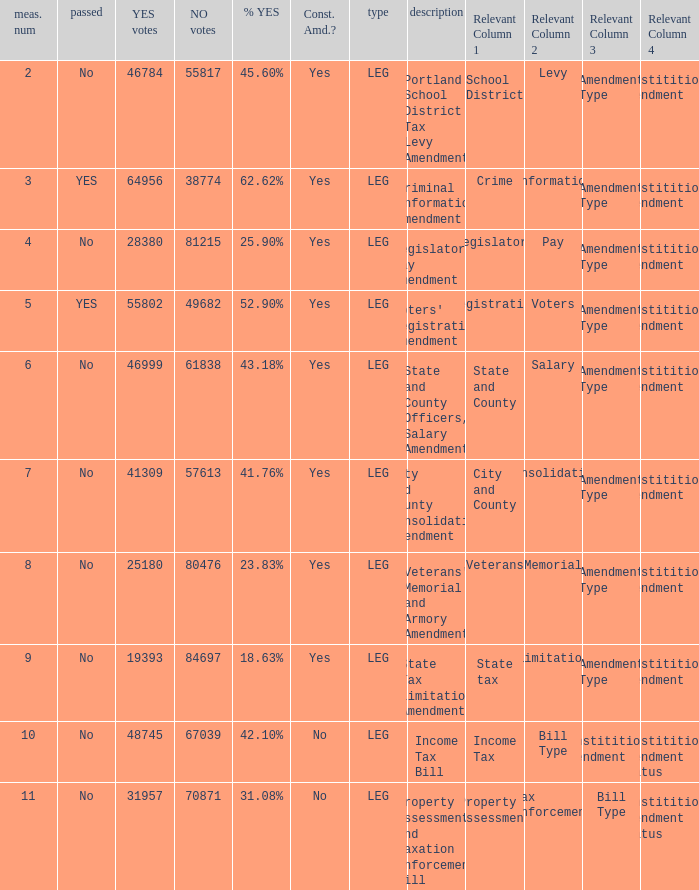Could you parse the entire table as a dict? {'header': ['meas. num', 'passed', 'YES votes', 'NO votes', '% YES', 'Const. Amd.?', 'type', 'description', 'Relevant Column 1', 'Relevant Column 2', 'Relevant Column 3', 'Relevant Column 4'], 'rows': [['2', 'No', '46784', '55817', '45.60%', 'Yes', 'LEG', 'Portland School District Tax Levy Amendment', 'School District', 'Levy', 'Amendment Type', 'Constititional Amendment'], ['3', 'YES', '64956', '38774', '62.62%', 'Yes', 'LEG', 'Criminal Information Amendment', 'Crime', 'Information', 'Amendment Type', 'Constititional Amendment'], ['4', 'No', '28380', '81215', '25.90%', 'Yes', 'LEG', "Legislators' Pay Amendment", 'Legislators', 'Pay', 'Amendment Type', 'Constititional Amendment'], ['5', 'YES', '55802', '49682', '52.90%', 'Yes', 'LEG', "Voters' Registration Amendment", 'Registration', 'Voters', 'Amendment Type', 'Constititional Amendment'], ['6', 'No', '46999', '61838', '43.18%', 'Yes', 'LEG', 'State and County Officers, Salary Amendment', 'State and County', 'Salary', 'Amendment Type', 'Constititional Amendment'], ['7', 'No', '41309', '57613', '41.76%', 'Yes', 'LEG', 'City and County Consolidation Amendment', 'City and County', 'Consolidation', 'Amendment Type', 'Constititional Amendment'], ['8', 'No', '25180', '80476', '23.83%', 'Yes', 'LEG', "Veterans' Memorial and Armory Amendment", 'Veterans', 'Memorial', 'Amendment Type', 'Constititional Amendment'], ['9', 'No', '19393', '84697', '18.63%', 'Yes', 'LEG', 'State Tax Limitation Amendment', 'State tax', 'Limitation', 'Amendment Type', 'Constititional Amendment'], ['10', 'No', '48745', '67039', '42.10%', 'No', 'LEG', 'Income Tax Bill', 'Income Tax', 'Bill Type', 'Constititional Amendment', 'Constititional Amendment Status'], ['11', 'No', '31957', '70871', '31.08%', 'No', 'LEG', 'Property Assessment and Taxation Enforcement Bill', 'Property Assessment', 'Tax Enforcement', 'Bill Type', 'Constititional Amendment Status']]} HOw many no votes were there when there were 45.60% yes votes 55817.0. 